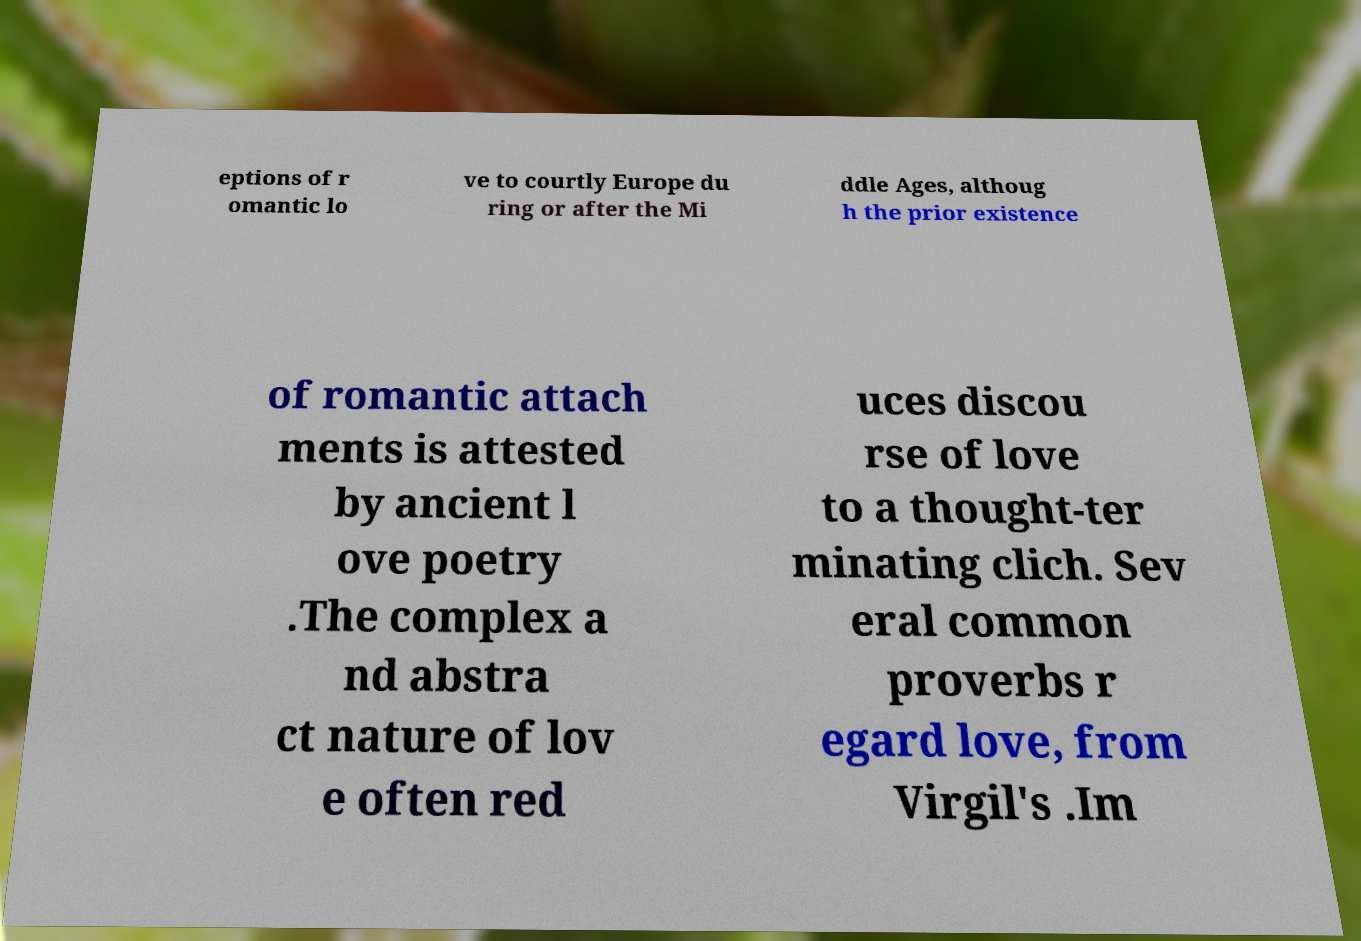What messages or text are displayed in this image? I need them in a readable, typed format. eptions of r omantic lo ve to courtly Europe du ring or after the Mi ddle Ages, althoug h the prior existence of romantic attach ments is attested by ancient l ove poetry .The complex a nd abstra ct nature of lov e often red uces discou rse of love to a thought-ter minating clich. Sev eral common proverbs r egard love, from Virgil's .Im 